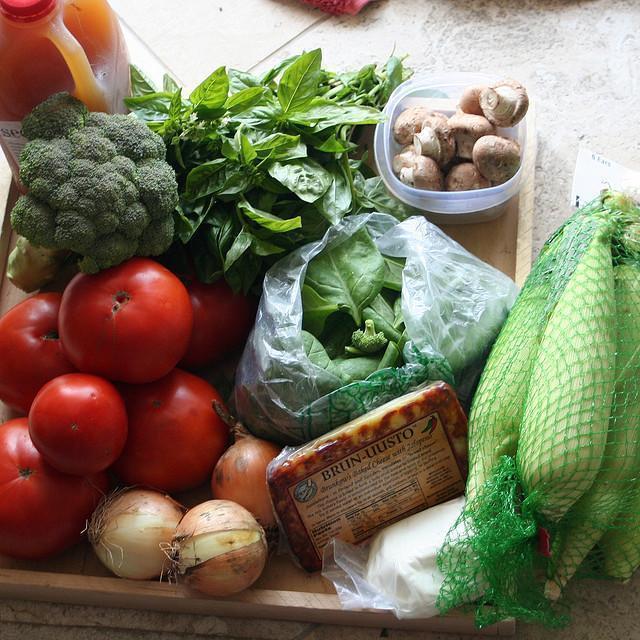What category of food is this?
Indicate the correct response by choosing from the four available options to answer the question.
Options: Vegetables, grains, meats, taco. Vegetables. 